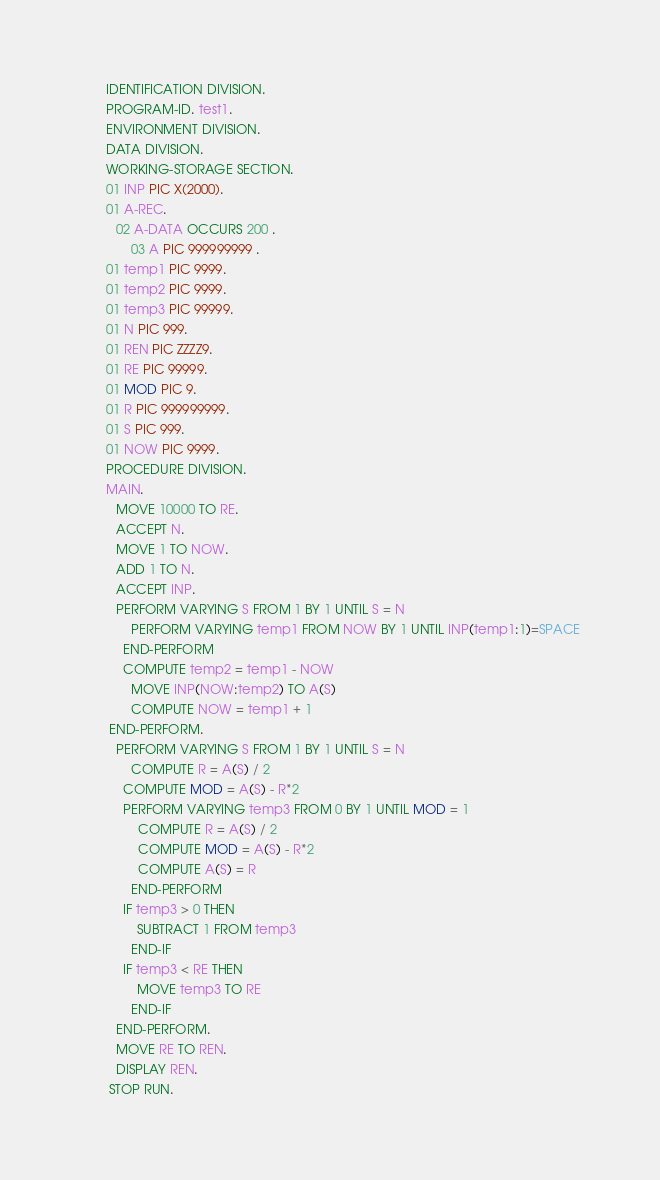Convert code to text. <code><loc_0><loc_0><loc_500><loc_500><_COBOL_>       IDENTIFICATION DIVISION.
       PROGRAM-ID. test1.
       ENVIRONMENT DIVISION.
       DATA DIVISION.
       WORKING-STORAGE SECTION.
       01 INP PIC X(2000).
       01 A-REC.
      	02 A-DATA OCCURS 200 .
      		03 A PIC 999999999 .
       01 temp1 PIC 9999.
       01 temp2 PIC 9999.
       01 temp3 PIC 99999.
       01 N PIC 999.
       01 REN PIC ZZZZ9.
       01 RE PIC 99999.
       01 MOD PIC 9.
       01 R PIC 999999999.
       01 S PIC 999.
       01 NOW PIC 9999.
       PROCEDURE DIVISION.
       MAIN.
      	MOVE 10000 TO RE.
      	ACCEPT N.
      	MOVE 1 TO NOW.
      	ADD 1 TO N.
      	ACCEPT INP.
      	PERFORM VARYING S FROM 1 BY 1 UNTIL S = N
      		PERFORM VARYING temp1 FROM NOW BY 1 UNTIL INP(temp1:1)=SPACE
      		END-PERFORM
      		COMPUTE temp2 = temp1 - NOW
      		MOVE INP(NOW:temp2) TO A(S)
      		COMPUTE NOW = temp1 + 1
      	END-PERFORM.
      	PERFORM VARYING S FROM 1 BY 1 UNTIL S = N
      		COMPUTE R = A(S) / 2
      		COMPUTE MOD = A(S) - R*2
      		PERFORM VARYING temp3 FROM 0 BY 1 UNTIL MOD = 1
      			COMPUTE R = A(S) / 2
      			COMPUTE MOD = A(S) - R*2
      			COMPUTE A(S) = R
      		END-PERFORM
      		IF temp3 > 0 THEN
      			SUBTRACT 1 FROM temp3
      		END-IF
      		IF temp3 < RE THEN
      			MOVE temp3 TO RE
      		END-IF
      	END-PERFORM.
      	MOVE RE TO REN.
      	DISPLAY REN.
        STOP RUN.


</code> 